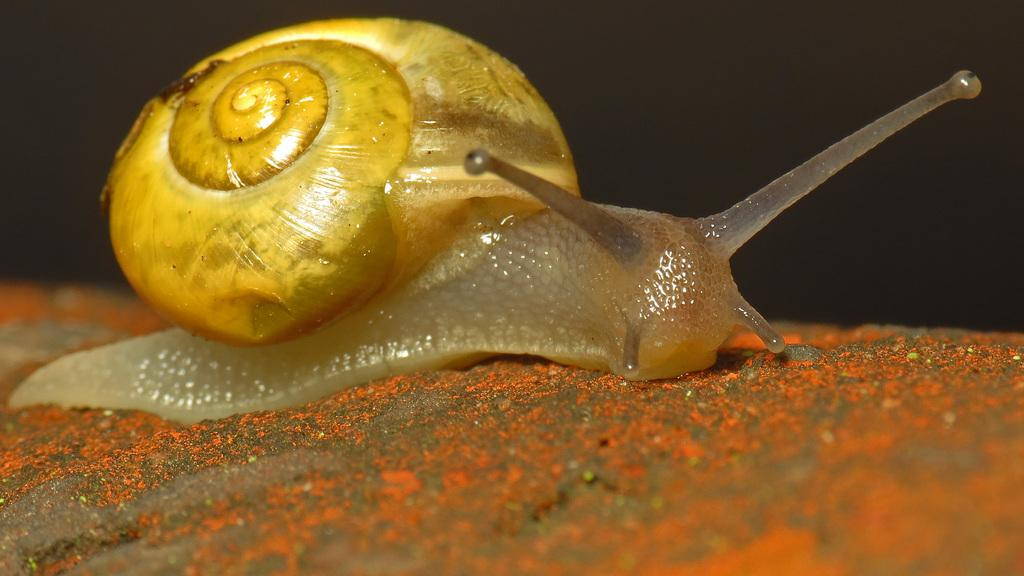What type of animal is in the image? There is a snail in the image. What colors can be seen on the snail? The snail is cream and yellow in color. What is the snail resting on in the image? The snail is on an orange and brown color surface. How would you describe the background of the image? The background of the image is dark. How many books does the snail have in its account in the image? There are no books or accounts mentioned in the image; it only features a snail on a surface with a dark background. 